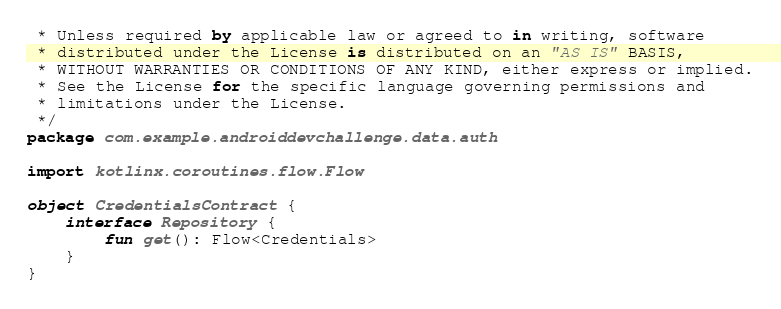Convert code to text. <code><loc_0><loc_0><loc_500><loc_500><_Kotlin_> * Unless required by applicable law or agreed to in writing, software
 * distributed under the License is distributed on an "AS IS" BASIS,
 * WITHOUT WARRANTIES OR CONDITIONS OF ANY KIND, either express or implied.
 * See the License for the specific language governing permissions and
 * limitations under the License.
 */
package com.example.androiddevchallenge.data.auth

import kotlinx.coroutines.flow.Flow

object CredentialsContract {
    interface Repository {
        fun get(): Flow<Credentials>
    }
}
</code> 